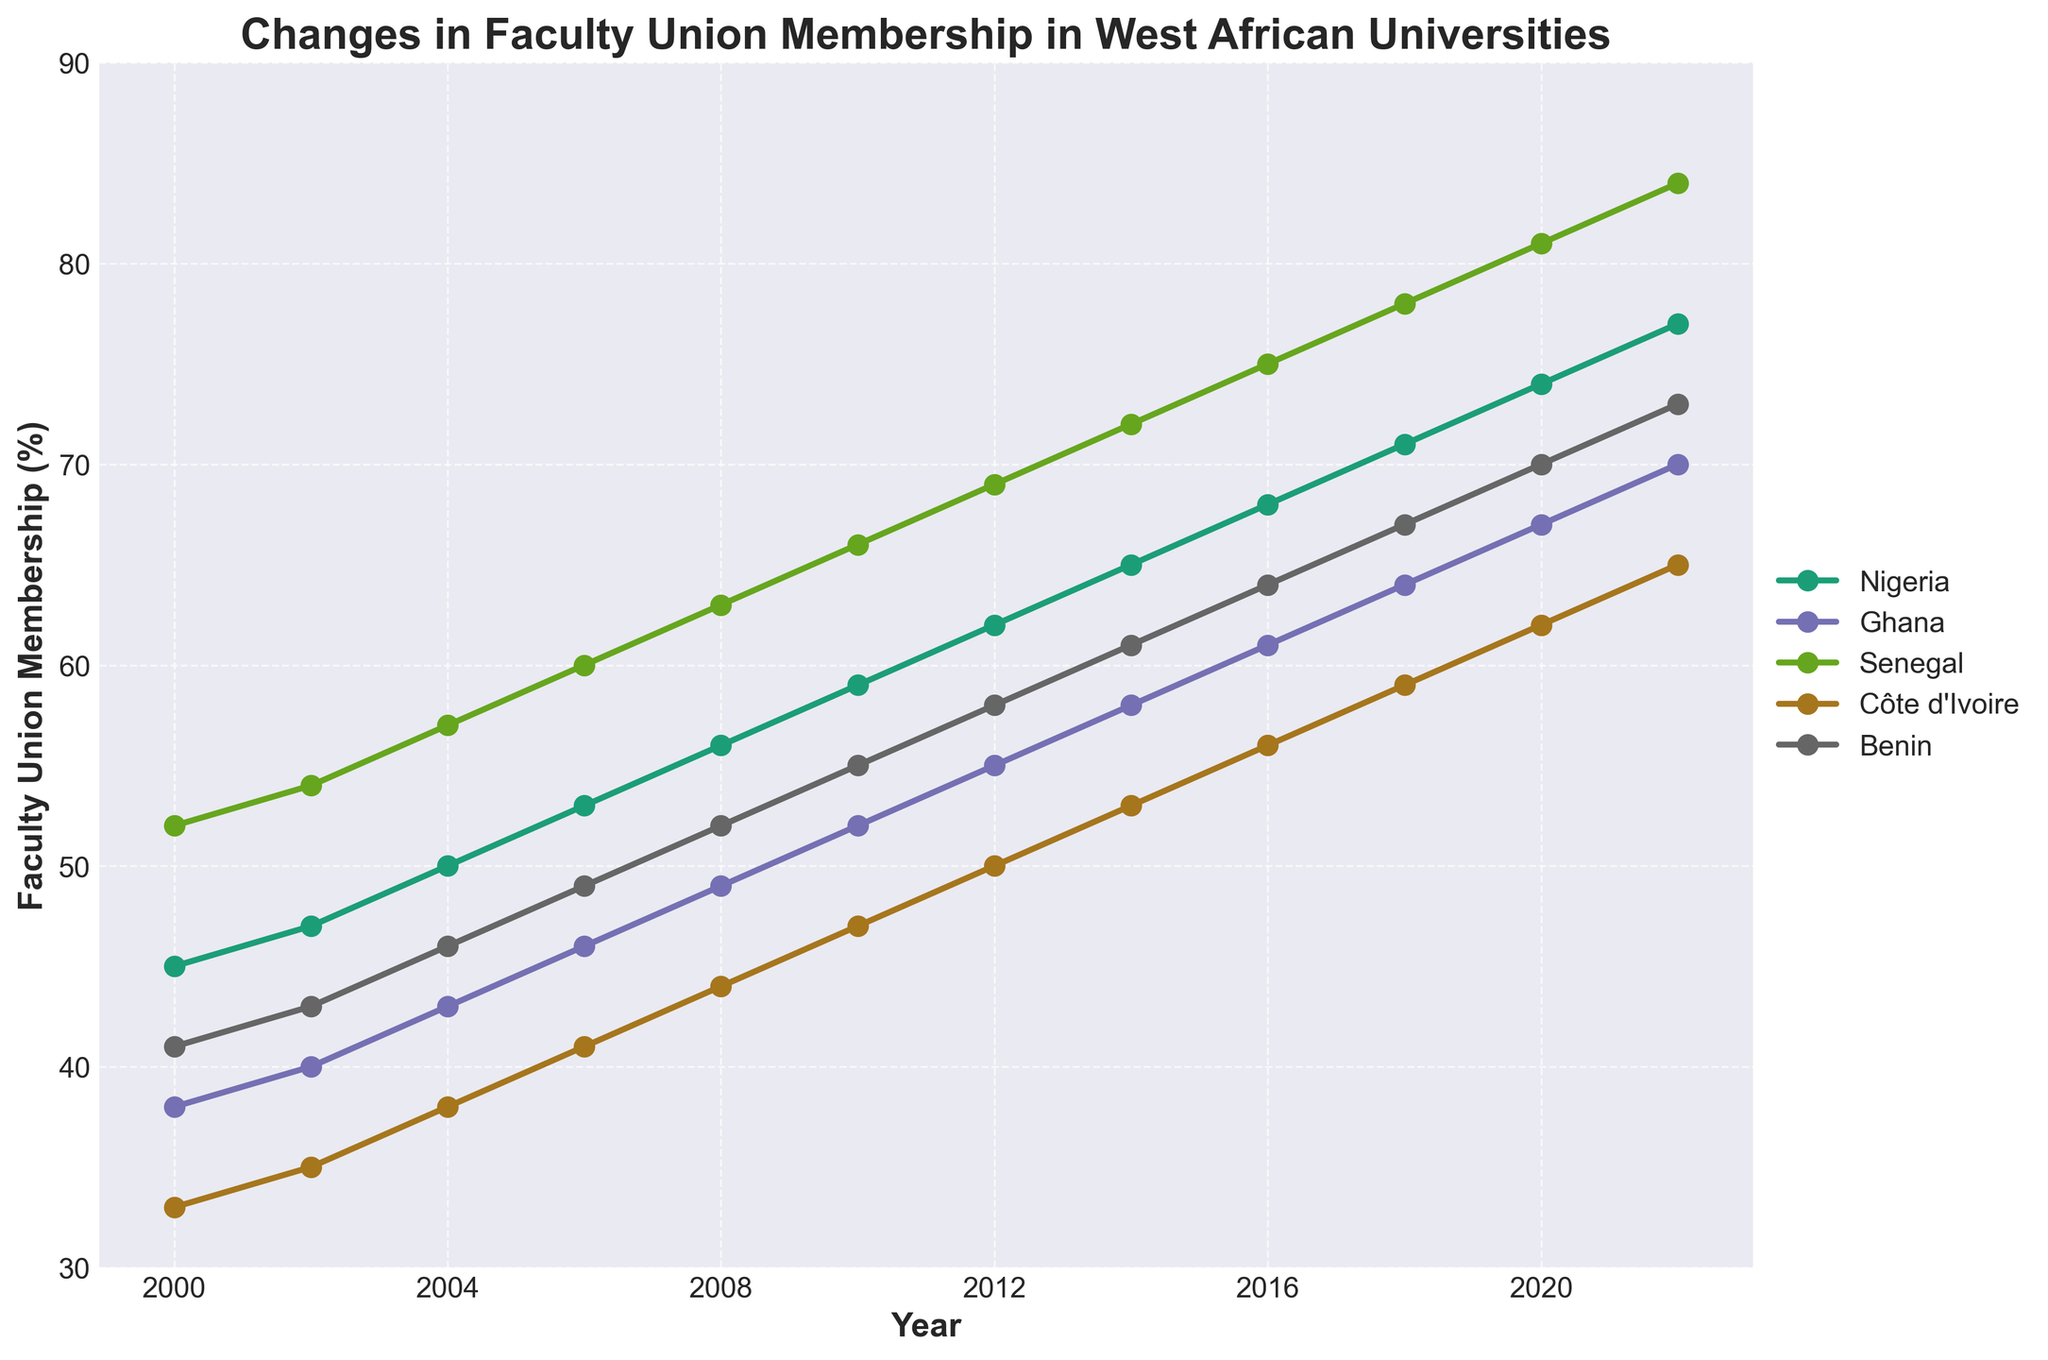What is the trend in faculty union membership in Nigeria from 2000 to 2022? Plot Nigeria's membership percentages from 2000 to 2022. Note that values consistently increase from 45% to 77%, demonstrating a clear upward trend.
Answer: Upward trend Which country had the highest faculty union membership percentage in 2022? Look at the year 2022 data points and identify which country has the highest value. Côte d'Ivoire has the highest value at 84%.
Answer: Côte d'Ivoire In which year did Ghana overtake Senegal in faculty union membership percentage? Compare the data for Ghana and Senegal year by year and identify when Ghana's percentage became greater than Senegal's. This first occurs in 2020 when Ghana's percentage (67%) exceeds Senegal's (62%).
Answer: 2020 By how much did the membership percentage in Benin increase from 2000 to 2022? Subtract the 2000 percentage (41%) from the 2022 percentage (73%) for Benin: 73% - 41% = 32%.
Answer: 32% Which countries experienced faculty union membership percentage growth of at least 30% from 2000 to 2022? Calculate the difference in membership percentages from 2000 to 2022 for each country and identify those with growth equal to or above 30%. Nigeria (32%), Ghana (32%), Senegal (32%), Côte d'Ivoire (32%), and Benin (32%) all saw growth of at least 30%.
Answer: Nigeria, Ghana, Senegal, Côte d'Ivoire, Benin What was the average faculty union membership percentage for all the countries in 2016? Add the membership percentages for all countries in 2016 (68 + 61 + 75 + 56 + 64) and divide by the number of countries (5): (68 + 61 + 75 + 56 + 64) / 5 = 324 / 5 = 64.8%.
Answer: 64.8% In which year did Côte d'Ivoire's faculty union membership percentage reach 50%? Look through the data points for Côte d'Ivoire and identify the first year it reaches 50%, which is 2012.
Answer: 2012 Which two countries had the closest membership percentages in 2008, and what was the difference? In 2008, Ghana (49%) and Benin (52%) had the closest values. The difference between them is 52% - 49% = 3%.
Answer: Ghana and Benin, 3% Compare the rate of increase in faculty union membership percentages for Nigeria and Senegal from 2000 to 2022. Which country's rate is higher? Calculate the increase for both countries from 2000 to 2022. Nigeria increased from 45% to 77%, a 32% increase. Senegal increased from 52% to 84%, also a 32% increase. Both countries have the same rate of increase (32%).
Answer: Equal When did all the countries first have a faculty union membership percentage above 50%? Identify the first year when all countries had their membership percentages above 50%. This happened in 2010, when Nigeria (59%) was the last to cross above 50%.
Answer: 2010 